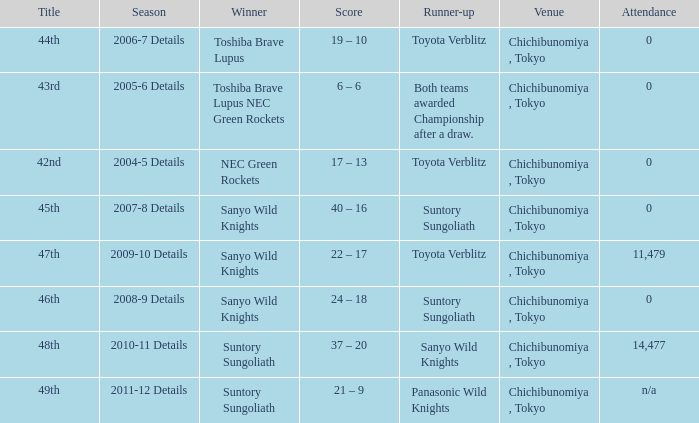Help me parse the entirety of this table. {'header': ['Title', 'Season', 'Winner', 'Score', 'Runner-up', 'Venue', 'Attendance'], 'rows': [['44th', '2006-7 Details', 'Toshiba Brave Lupus', '19 – 10', 'Toyota Verblitz', 'Chichibunomiya , Tokyo', '0'], ['43rd', '2005-6 Details', 'Toshiba Brave Lupus NEC Green Rockets', '6 – 6', 'Both teams awarded Championship after a draw.', 'Chichibunomiya , Tokyo', '0'], ['42nd', '2004-5 Details', 'NEC Green Rockets', '17 – 13', 'Toyota Verblitz', 'Chichibunomiya , Tokyo', '0'], ['45th', '2007-8 Details', 'Sanyo Wild Knights', '40 – 16', 'Suntory Sungoliath', 'Chichibunomiya , Tokyo', '0'], ['47th', '2009-10 Details', 'Sanyo Wild Knights', '22 – 17', 'Toyota Verblitz', 'Chichibunomiya , Tokyo', '11,479'], ['46th', '2008-9 Details', 'Sanyo Wild Knights', '24 – 18', 'Suntory Sungoliath', 'Chichibunomiya , Tokyo', '0'], ['48th', '2010-11 Details', 'Suntory Sungoliath', '37 – 20', 'Sanyo Wild Knights', 'Chichibunomiya , Tokyo', '14,477'], ['49th', '2011-12 Details', 'Suntory Sungoliath', '21 – 9', 'Panasonic Wild Knights', 'Chichibunomiya , Tokyo', 'n/a']]} What is the Title when the winner was suntory sungoliath, and a Season of 2011-12 details? 49th. 